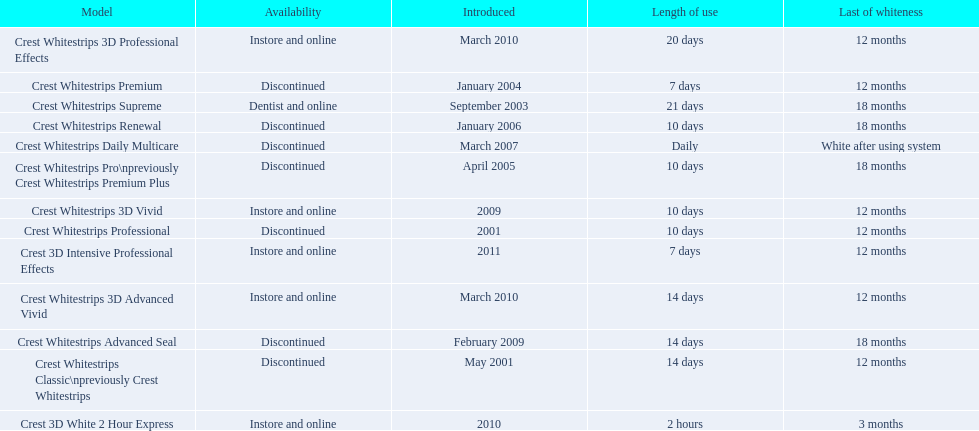What are all of the model names? Crest Whitestrips Classic\npreviously Crest Whitestrips, Crest Whitestrips Professional, Crest Whitestrips Supreme, Crest Whitestrips Premium, Crest Whitestrips Pro\npreviously Crest Whitestrips Premium Plus, Crest Whitestrips Renewal, Crest Whitestrips Daily Multicare, Crest Whitestrips Advanced Seal, Crest Whitestrips 3D Vivid, Crest Whitestrips 3D Advanced Vivid, Crest Whitestrips 3D Professional Effects, Crest 3D White 2 Hour Express, Crest 3D Intensive Professional Effects. When were they first introduced? May 2001, 2001, September 2003, January 2004, April 2005, January 2006, March 2007, February 2009, 2009, March 2010, March 2010, 2010, 2011. Along with crest whitestrips 3d advanced vivid, which other model was introduced in march 2010? Crest Whitestrips 3D Professional Effects. 